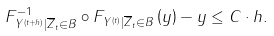Convert formula to latex. <formula><loc_0><loc_0><loc_500><loc_500>F _ { Y ^ { ( t + h ) } | \overline { Z } _ { t } \in B } ^ { - 1 } \circ F _ { Y ^ { ( t ) } | \overline { Z } _ { t } \in B } \left ( y \right ) - y \leq C \cdot h .</formula> 